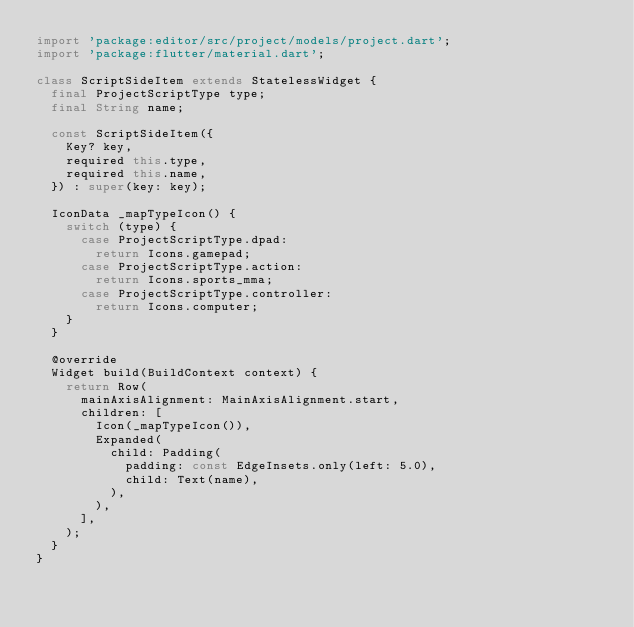Convert code to text. <code><loc_0><loc_0><loc_500><loc_500><_Dart_>import 'package:editor/src/project/models/project.dart';
import 'package:flutter/material.dart';

class ScriptSideItem extends StatelessWidget {
  final ProjectScriptType type;
  final String name;

  const ScriptSideItem({
    Key? key,
    required this.type,
    required this.name,
  }) : super(key: key);

  IconData _mapTypeIcon() {
    switch (type) {
      case ProjectScriptType.dpad:
        return Icons.gamepad;
      case ProjectScriptType.action:
        return Icons.sports_mma;
      case ProjectScriptType.controller:
        return Icons.computer;
    }
  }

  @override
  Widget build(BuildContext context) {
    return Row(
      mainAxisAlignment: MainAxisAlignment.start,
      children: [
        Icon(_mapTypeIcon()),
        Expanded(
          child: Padding(
            padding: const EdgeInsets.only(left: 5.0),
            child: Text(name),
          ),
        ),
      ],
    );
  }
}
</code> 